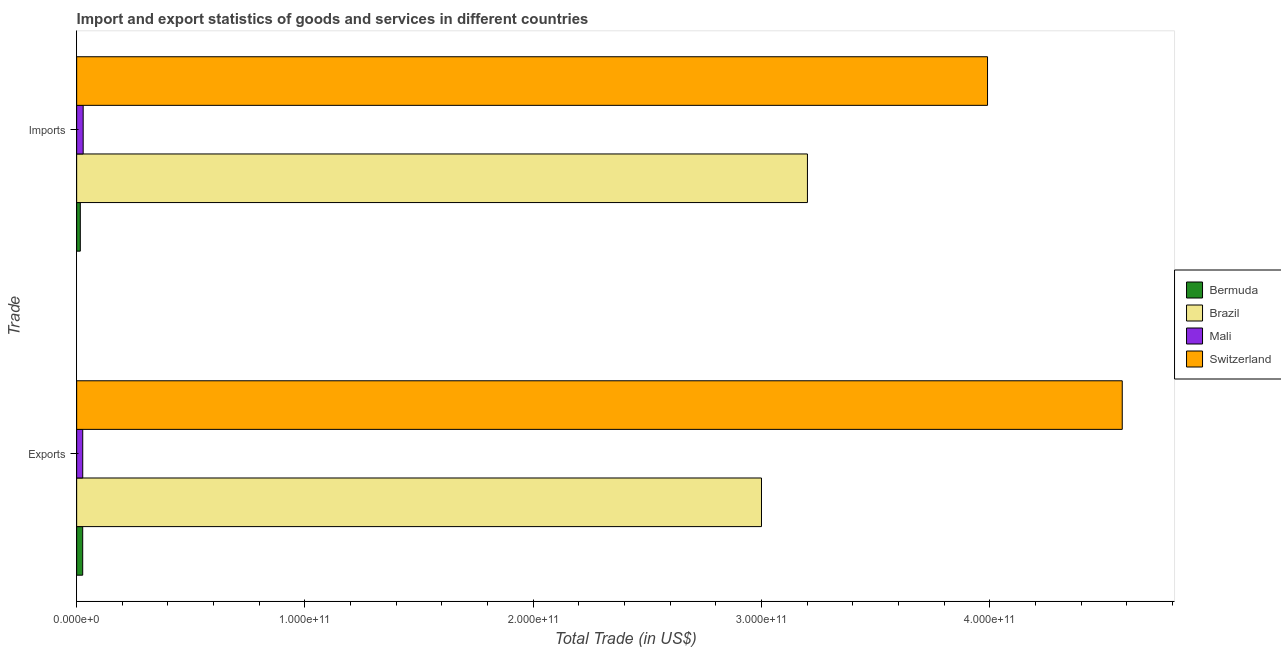How many groups of bars are there?
Your answer should be very brief. 2. Are the number of bars per tick equal to the number of legend labels?
Keep it short and to the point. Yes. How many bars are there on the 1st tick from the bottom?
Give a very brief answer. 4. What is the label of the 2nd group of bars from the top?
Ensure brevity in your answer.  Exports. What is the export of goods and services in Bermuda?
Offer a very short reply. 2.64e+09. Across all countries, what is the maximum imports of goods and services?
Give a very brief answer. 3.99e+11. Across all countries, what is the minimum imports of goods and services?
Give a very brief answer. 1.60e+09. In which country was the export of goods and services maximum?
Provide a succinct answer. Switzerland. In which country was the export of goods and services minimum?
Your response must be concise. Bermuda. What is the total export of goods and services in the graph?
Your answer should be very brief. 7.63e+11. What is the difference between the imports of goods and services in Bermuda and that in Brazil?
Offer a very short reply. -3.19e+11. What is the difference between the export of goods and services in Brazil and the imports of goods and services in Mali?
Provide a short and direct response. 2.97e+11. What is the average export of goods and services per country?
Your answer should be compact. 1.91e+11. What is the difference between the imports of goods and services and export of goods and services in Mali?
Make the answer very short. 1.92e+08. What is the ratio of the export of goods and services in Brazil to that in Mali?
Provide a succinct answer. 112.87. Is the imports of goods and services in Mali less than that in Switzerland?
Offer a terse response. Yes. In how many countries, is the imports of goods and services greater than the average imports of goods and services taken over all countries?
Give a very brief answer. 2. What does the 2nd bar from the top in Imports represents?
Make the answer very short. Mali. What does the 3rd bar from the bottom in Exports represents?
Offer a very short reply. Mali. How many countries are there in the graph?
Provide a succinct answer. 4. What is the difference between two consecutive major ticks on the X-axis?
Keep it short and to the point. 1.00e+11. Does the graph contain any zero values?
Make the answer very short. No. Does the graph contain grids?
Keep it short and to the point. No. Where does the legend appear in the graph?
Ensure brevity in your answer.  Center right. How many legend labels are there?
Your answer should be very brief. 4. What is the title of the graph?
Your answer should be compact. Import and export statistics of goods and services in different countries. What is the label or title of the X-axis?
Make the answer very short. Total Trade (in US$). What is the label or title of the Y-axis?
Ensure brevity in your answer.  Trade. What is the Total Trade (in US$) of Bermuda in Exports?
Provide a short and direct response. 2.64e+09. What is the Total Trade (in US$) in Brazil in Exports?
Give a very brief answer. 3.00e+11. What is the Total Trade (in US$) in Mali in Exports?
Provide a succinct answer. 2.66e+09. What is the Total Trade (in US$) in Switzerland in Exports?
Give a very brief answer. 4.58e+11. What is the Total Trade (in US$) in Bermuda in Imports?
Your answer should be compact. 1.60e+09. What is the Total Trade (in US$) in Brazil in Imports?
Keep it short and to the point. 3.20e+11. What is the Total Trade (in US$) in Mali in Imports?
Make the answer very short. 2.85e+09. What is the Total Trade (in US$) in Switzerland in Imports?
Your answer should be very brief. 3.99e+11. Across all Trade, what is the maximum Total Trade (in US$) of Bermuda?
Offer a very short reply. 2.64e+09. Across all Trade, what is the maximum Total Trade (in US$) of Brazil?
Make the answer very short. 3.20e+11. Across all Trade, what is the maximum Total Trade (in US$) in Mali?
Provide a short and direct response. 2.85e+09. Across all Trade, what is the maximum Total Trade (in US$) in Switzerland?
Your answer should be very brief. 4.58e+11. Across all Trade, what is the minimum Total Trade (in US$) of Bermuda?
Make the answer very short. 1.60e+09. Across all Trade, what is the minimum Total Trade (in US$) in Brazil?
Give a very brief answer. 3.00e+11. Across all Trade, what is the minimum Total Trade (in US$) of Mali?
Keep it short and to the point. 2.66e+09. Across all Trade, what is the minimum Total Trade (in US$) in Switzerland?
Your answer should be compact. 3.99e+11. What is the total Total Trade (in US$) in Bermuda in the graph?
Provide a short and direct response. 4.25e+09. What is the total Total Trade (in US$) of Brazil in the graph?
Your answer should be very brief. 6.20e+11. What is the total Total Trade (in US$) in Mali in the graph?
Keep it short and to the point. 5.51e+09. What is the total Total Trade (in US$) in Switzerland in the graph?
Keep it short and to the point. 8.57e+11. What is the difference between the Total Trade (in US$) in Bermuda in Exports and that in Imports?
Provide a succinct answer. 1.04e+09. What is the difference between the Total Trade (in US$) in Brazil in Exports and that in Imports?
Your answer should be compact. -2.01e+1. What is the difference between the Total Trade (in US$) in Mali in Exports and that in Imports?
Offer a terse response. -1.92e+08. What is the difference between the Total Trade (in US$) in Switzerland in Exports and that in Imports?
Offer a very short reply. 5.90e+1. What is the difference between the Total Trade (in US$) of Bermuda in Exports and the Total Trade (in US$) of Brazil in Imports?
Provide a succinct answer. -3.17e+11. What is the difference between the Total Trade (in US$) in Bermuda in Exports and the Total Trade (in US$) in Mali in Imports?
Offer a very short reply. -2.05e+08. What is the difference between the Total Trade (in US$) of Bermuda in Exports and the Total Trade (in US$) of Switzerland in Imports?
Ensure brevity in your answer.  -3.96e+11. What is the difference between the Total Trade (in US$) of Brazil in Exports and the Total Trade (in US$) of Mali in Imports?
Ensure brevity in your answer.  2.97e+11. What is the difference between the Total Trade (in US$) in Brazil in Exports and the Total Trade (in US$) in Switzerland in Imports?
Keep it short and to the point. -9.90e+1. What is the difference between the Total Trade (in US$) in Mali in Exports and the Total Trade (in US$) in Switzerland in Imports?
Offer a very short reply. -3.96e+11. What is the average Total Trade (in US$) of Bermuda per Trade?
Your response must be concise. 2.12e+09. What is the average Total Trade (in US$) of Brazil per Trade?
Make the answer very short. 3.10e+11. What is the average Total Trade (in US$) in Mali per Trade?
Your response must be concise. 2.75e+09. What is the average Total Trade (in US$) in Switzerland per Trade?
Give a very brief answer. 4.28e+11. What is the difference between the Total Trade (in US$) of Bermuda and Total Trade (in US$) of Brazil in Exports?
Provide a short and direct response. -2.97e+11. What is the difference between the Total Trade (in US$) in Bermuda and Total Trade (in US$) in Mali in Exports?
Provide a short and direct response. -1.35e+07. What is the difference between the Total Trade (in US$) in Bermuda and Total Trade (in US$) in Switzerland in Exports?
Give a very brief answer. -4.55e+11. What is the difference between the Total Trade (in US$) in Brazil and Total Trade (in US$) in Mali in Exports?
Give a very brief answer. 2.97e+11. What is the difference between the Total Trade (in US$) in Brazil and Total Trade (in US$) in Switzerland in Exports?
Give a very brief answer. -1.58e+11. What is the difference between the Total Trade (in US$) in Mali and Total Trade (in US$) in Switzerland in Exports?
Your answer should be very brief. -4.55e+11. What is the difference between the Total Trade (in US$) in Bermuda and Total Trade (in US$) in Brazil in Imports?
Ensure brevity in your answer.  -3.19e+11. What is the difference between the Total Trade (in US$) in Bermuda and Total Trade (in US$) in Mali in Imports?
Offer a very short reply. -1.25e+09. What is the difference between the Total Trade (in US$) in Bermuda and Total Trade (in US$) in Switzerland in Imports?
Your answer should be very brief. -3.97e+11. What is the difference between the Total Trade (in US$) in Brazil and Total Trade (in US$) in Mali in Imports?
Your answer should be compact. 3.17e+11. What is the difference between the Total Trade (in US$) of Brazil and Total Trade (in US$) of Switzerland in Imports?
Ensure brevity in your answer.  -7.89e+1. What is the difference between the Total Trade (in US$) in Mali and Total Trade (in US$) in Switzerland in Imports?
Your answer should be compact. -3.96e+11. What is the ratio of the Total Trade (in US$) of Bermuda in Exports to that in Imports?
Your response must be concise. 1.65. What is the ratio of the Total Trade (in US$) of Brazil in Exports to that in Imports?
Offer a very short reply. 0.94. What is the ratio of the Total Trade (in US$) in Mali in Exports to that in Imports?
Your response must be concise. 0.93. What is the ratio of the Total Trade (in US$) in Switzerland in Exports to that in Imports?
Your answer should be compact. 1.15. What is the difference between the highest and the second highest Total Trade (in US$) of Bermuda?
Offer a terse response. 1.04e+09. What is the difference between the highest and the second highest Total Trade (in US$) of Brazil?
Offer a very short reply. 2.01e+1. What is the difference between the highest and the second highest Total Trade (in US$) in Mali?
Your answer should be very brief. 1.92e+08. What is the difference between the highest and the second highest Total Trade (in US$) in Switzerland?
Offer a very short reply. 5.90e+1. What is the difference between the highest and the lowest Total Trade (in US$) in Bermuda?
Offer a terse response. 1.04e+09. What is the difference between the highest and the lowest Total Trade (in US$) of Brazil?
Your response must be concise. 2.01e+1. What is the difference between the highest and the lowest Total Trade (in US$) in Mali?
Ensure brevity in your answer.  1.92e+08. What is the difference between the highest and the lowest Total Trade (in US$) in Switzerland?
Ensure brevity in your answer.  5.90e+1. 